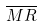<formula> <loc_0><loc_0><loc_500><loc_500>\overline { M R }</formula> 